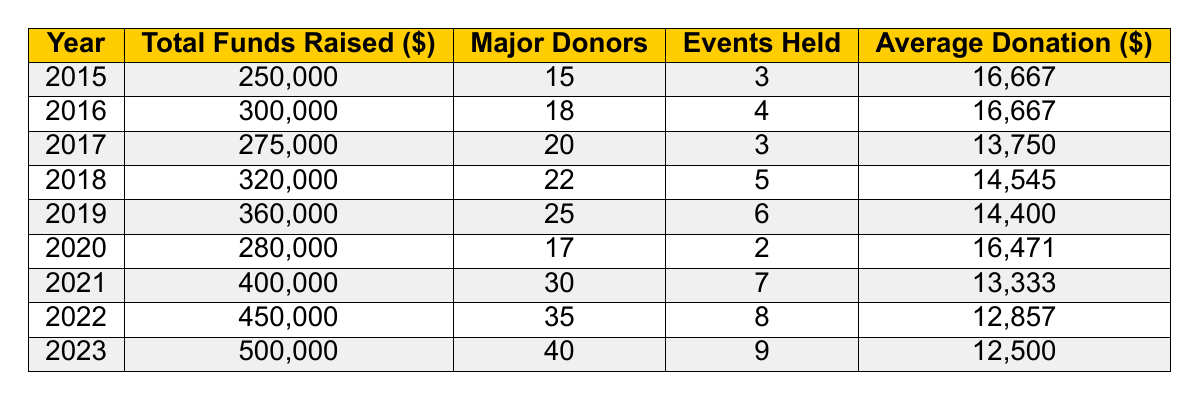What was the total funds raised in 2020? By looking at the table, I can see the data for the year 2020 under the column "Total Funds Raised" shows 280,000.
Answer: 280,000 In which year did the University of Iowa baseball program raise the highest total funds? The table shows the total funds raised for each year, and comparing them reveals that 2023 had the highest total at 500,000.
Answer: 2023 How many major donors were there in 2019? Referring to the table, the number of major donors listed for 2019 is 25.
Answer: 25 What is the average donation for the year 2017? The average donation for 2017 is given in the table as 13,750.
Answer: 13,750 Did the number of events held in 2022 exceed the number held in 2015? The table shows that 2022 had 8 events, while 2015 had 3 events, so 2022's count is greater than 2015's count. Therefore, the statement is true.
Answer: Yes What was the increase in total funds raised from 2015 to 2022? To find the increase, subtract the total funds raised in 2015 (250,000) from the total raised in 2022 (450,000). So, 450,000 - 250,000 equals 200,000.
Answer: 200,000 What was the average number of events held from 2015 to 2023? Adding the events held each year from 2015 to 2023 gives us a total of 3 + 4 + 3 + 5 + 6 + 2 + 7 + 8 + 9 = 47. Since there are 9 years, we divide 47 by 9 to get an average of approximately 5.22.
Answer: 5.22 Was there an increase or decrease in total funds raised from 2019 to 2020? The total for 2019 is 360,000 and for 2020 it is 280,000. Since 280,000 is less than 360,000, it shows a decrease.
Answer: Decrease What is the median of the average donations from 2015 to 2023? The average donations listed are: 16,667, 16,667, 13,750, 14,545, 14,400, 16,471, 13,333, 12,857, 12,500. Ordering these gives: 12,500, 12,857, 13,333, 13,750, 14,400, 14,545, 16,471, 16,667, 16,667. The median (middle value) for 9 values is the 5th one, which is 14,400.
Answer: 14,400 